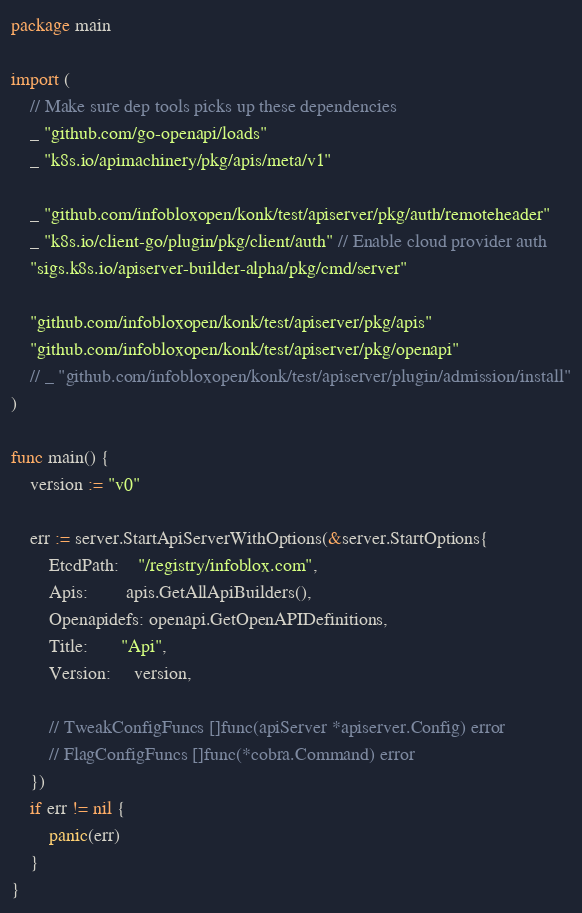<code> <loc_0><loc_0><loc_500><loc_500><_Go_>package main

import (
	// Make sure dep tools picks up these dependencies
	_ "github.com/go-openapi/loads"
	_ "k8s.io/apimachinery/pkg/apis/meta/v1"

	_ "github.com/infobloxopen/konk/test/apiserver/pkg/auth/remoteheader"
	_ "k8s.io/client-go/plugin/pkg/client/auth" // Enable cloud provider auth
	"sigs.k8s.io/apiserver-builder-alpha/pkg/cmd/server"

	"github.com/infobloxopen/konk/test/apiserver/pkg/apis"
	"github.com/infobloxopen/konk/test/apiserver/pkg/openapi"
	// _ "github.com/infobloxopen/konk/test/apiserver/plugin/admission/install"
)

func main() {
	version := "v0"

	err := server.StartApiServerWithOptions(&server.StartOptions{
		EtcdPath:    "/registry/infoblox.com",
		Apis:        apis.GetAllApiBuilders(),
		Openapidefs: openapi.GetOpenAPIDefinitions,
		Title:       "Api",
		Version:     version,

		// TweakConfigFuncs []func(apiServer *apiserver.Config) error
		// FlagConfigFuncs []func(*cobra.Command) error
	})
	if err != nil {
		panic(err)
	}
}
</code> 